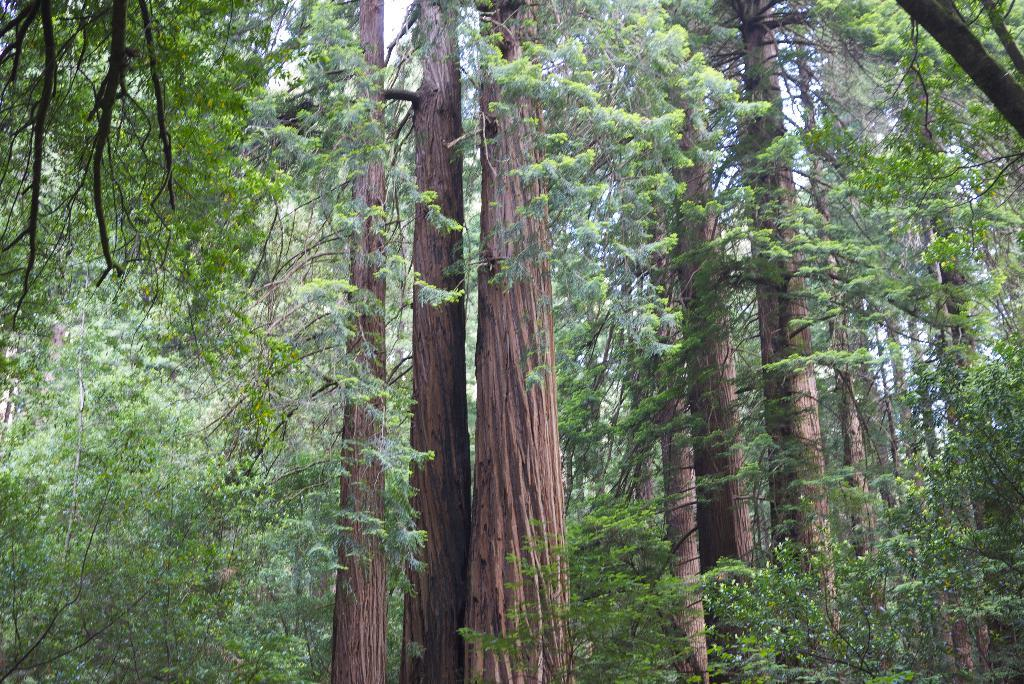What type of vegetation is visible in the image? There are many trees in the image. What part of the natural environment is visible in the image? The sky is visible in the background of the image. How does the crow express regret in the image? There is no crow present in the image, and therefore no such expression of regret can be observed. 